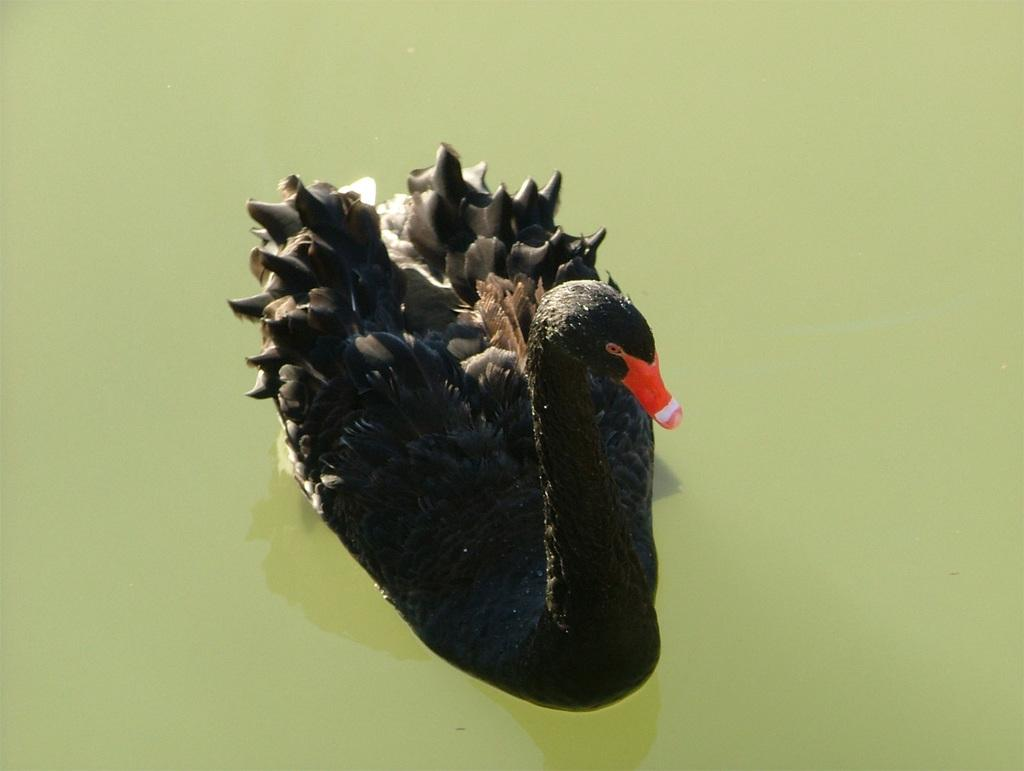What animal is present in the image? There is a duck in the image. What color is the duck? The duck is black in color. What is the duck doing in the image? The duck is swimming in the water. Where can the apple be found in the image? There is no apple present in the image. Is the duck located in a zoo in the image? The image does not provide any information about the location of the duck, so it cannot be determined if it is in a zoo or not. 